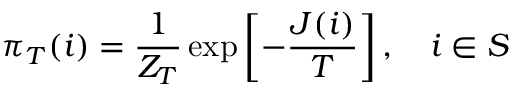<formula> <loc_0><loc_0><loc_500><loc_500>\pi _ { T } ( i ) = \frac { 1 } { Z _ { T } } \exp \left [ - \frac { J ( i ) } { T } \right ] , \quad i \in S</formula> 